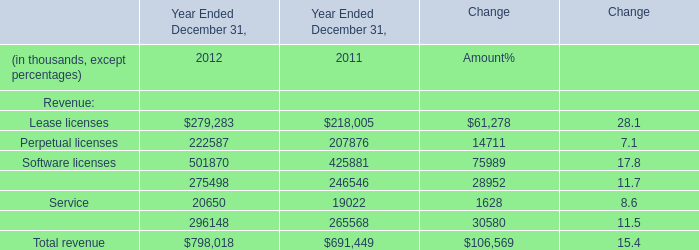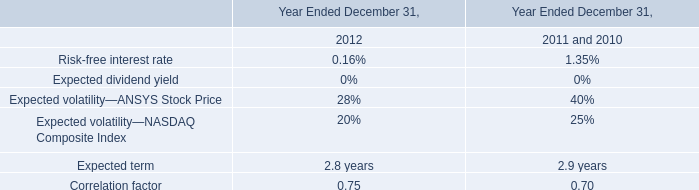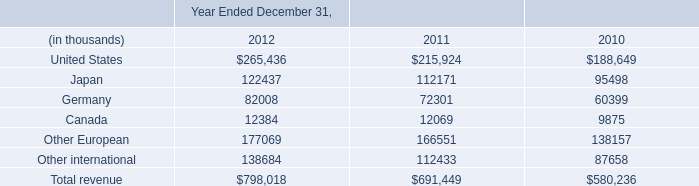What is the total amount of Perpetual licenses of Year Ended December 31, 2012, and Germany of Year Ended December 31, 2010 ? 
Computations: (222587.0 + 60399.0)
Answer: 282986.0. 